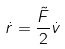Convert formula to latex. <formula><loc_0><loc_0><loc_500><loc_500>\dot { r } = \frac { \tilde { F } } { 2 } \dot { v }</formula> 